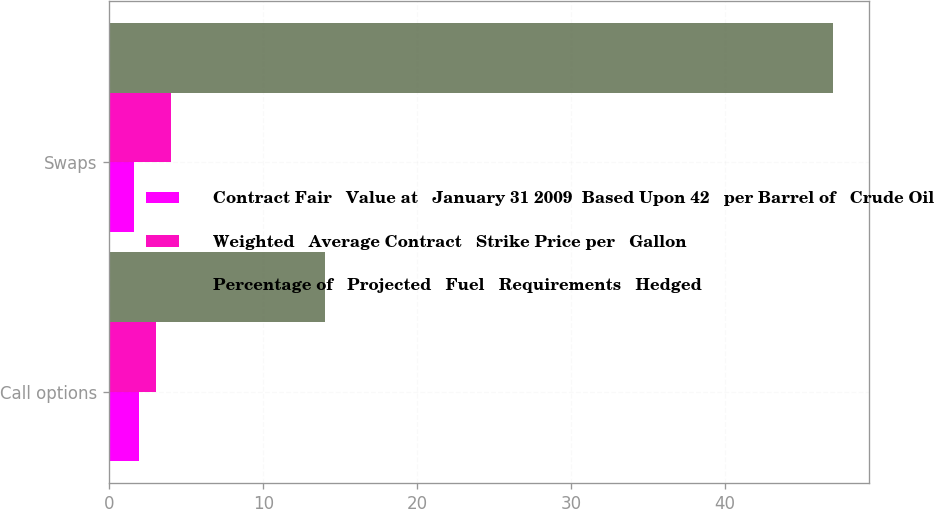<chart> <loc_0><loc_0><loc_500><loc_500><stacked_bar_chart><ecel><fcel>Call options<fcel>Swaps<nl><fcel>Contract Fair   Value at   January 31 2009  Based Upon 42   per Barrel of   Crude Oil<fcel>1.9<fcel>1.58<nl><fcel>Weighted   Average Contract   Strike Price per   Gallon<fcel>3<fcel>4<nl><fcel>Percentage of   Projected   Fuel   Requirements   Hedged<fcel>14<fcel>47<nl></chart> 